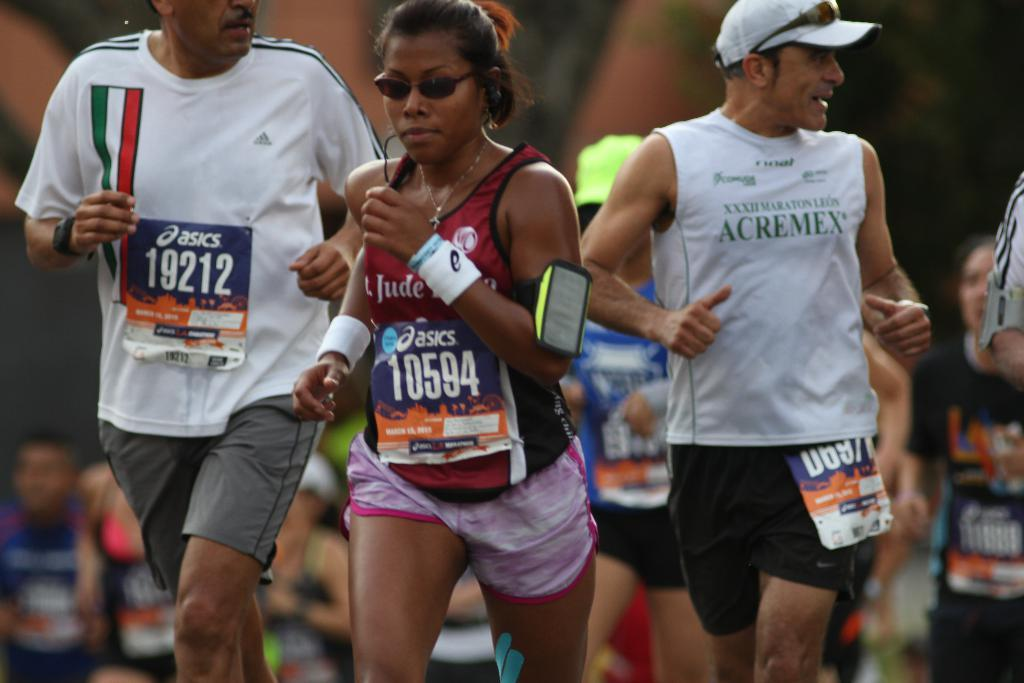Who or what is present in the image? There are people in the image. What are the people doing in the image? The people are running. What type of vegetable is being used as a prop by the people in the image? There is no vegetable present in the image; the people are running without any props. 